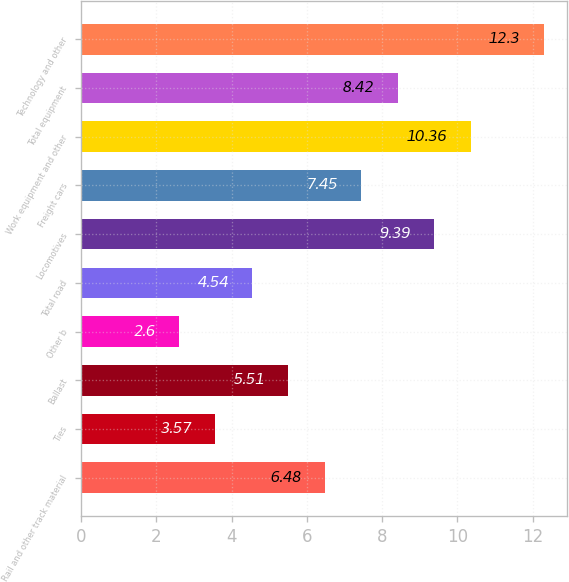Convert chart. <chart><loc_0><loc_0><loc_500><loc_500><bar_chart><fcel>Rail and other track material<fcel>Ties<fcel>Ballast<fcel>Other b<fcel>Total road<fcel>Locomotives<fcel>Freight cars<fcel>Work equipment and other<fcel>Total equipment<fcel>Technology and other<nl><fcel>6.48<fcel>3.57<fcel>5.51<fcel>2.6<fcel>4.54<fcel>9.39<fcel>7.45<fcel>10.36<fcel>8.42<fcel>12.3<nl></chart> 